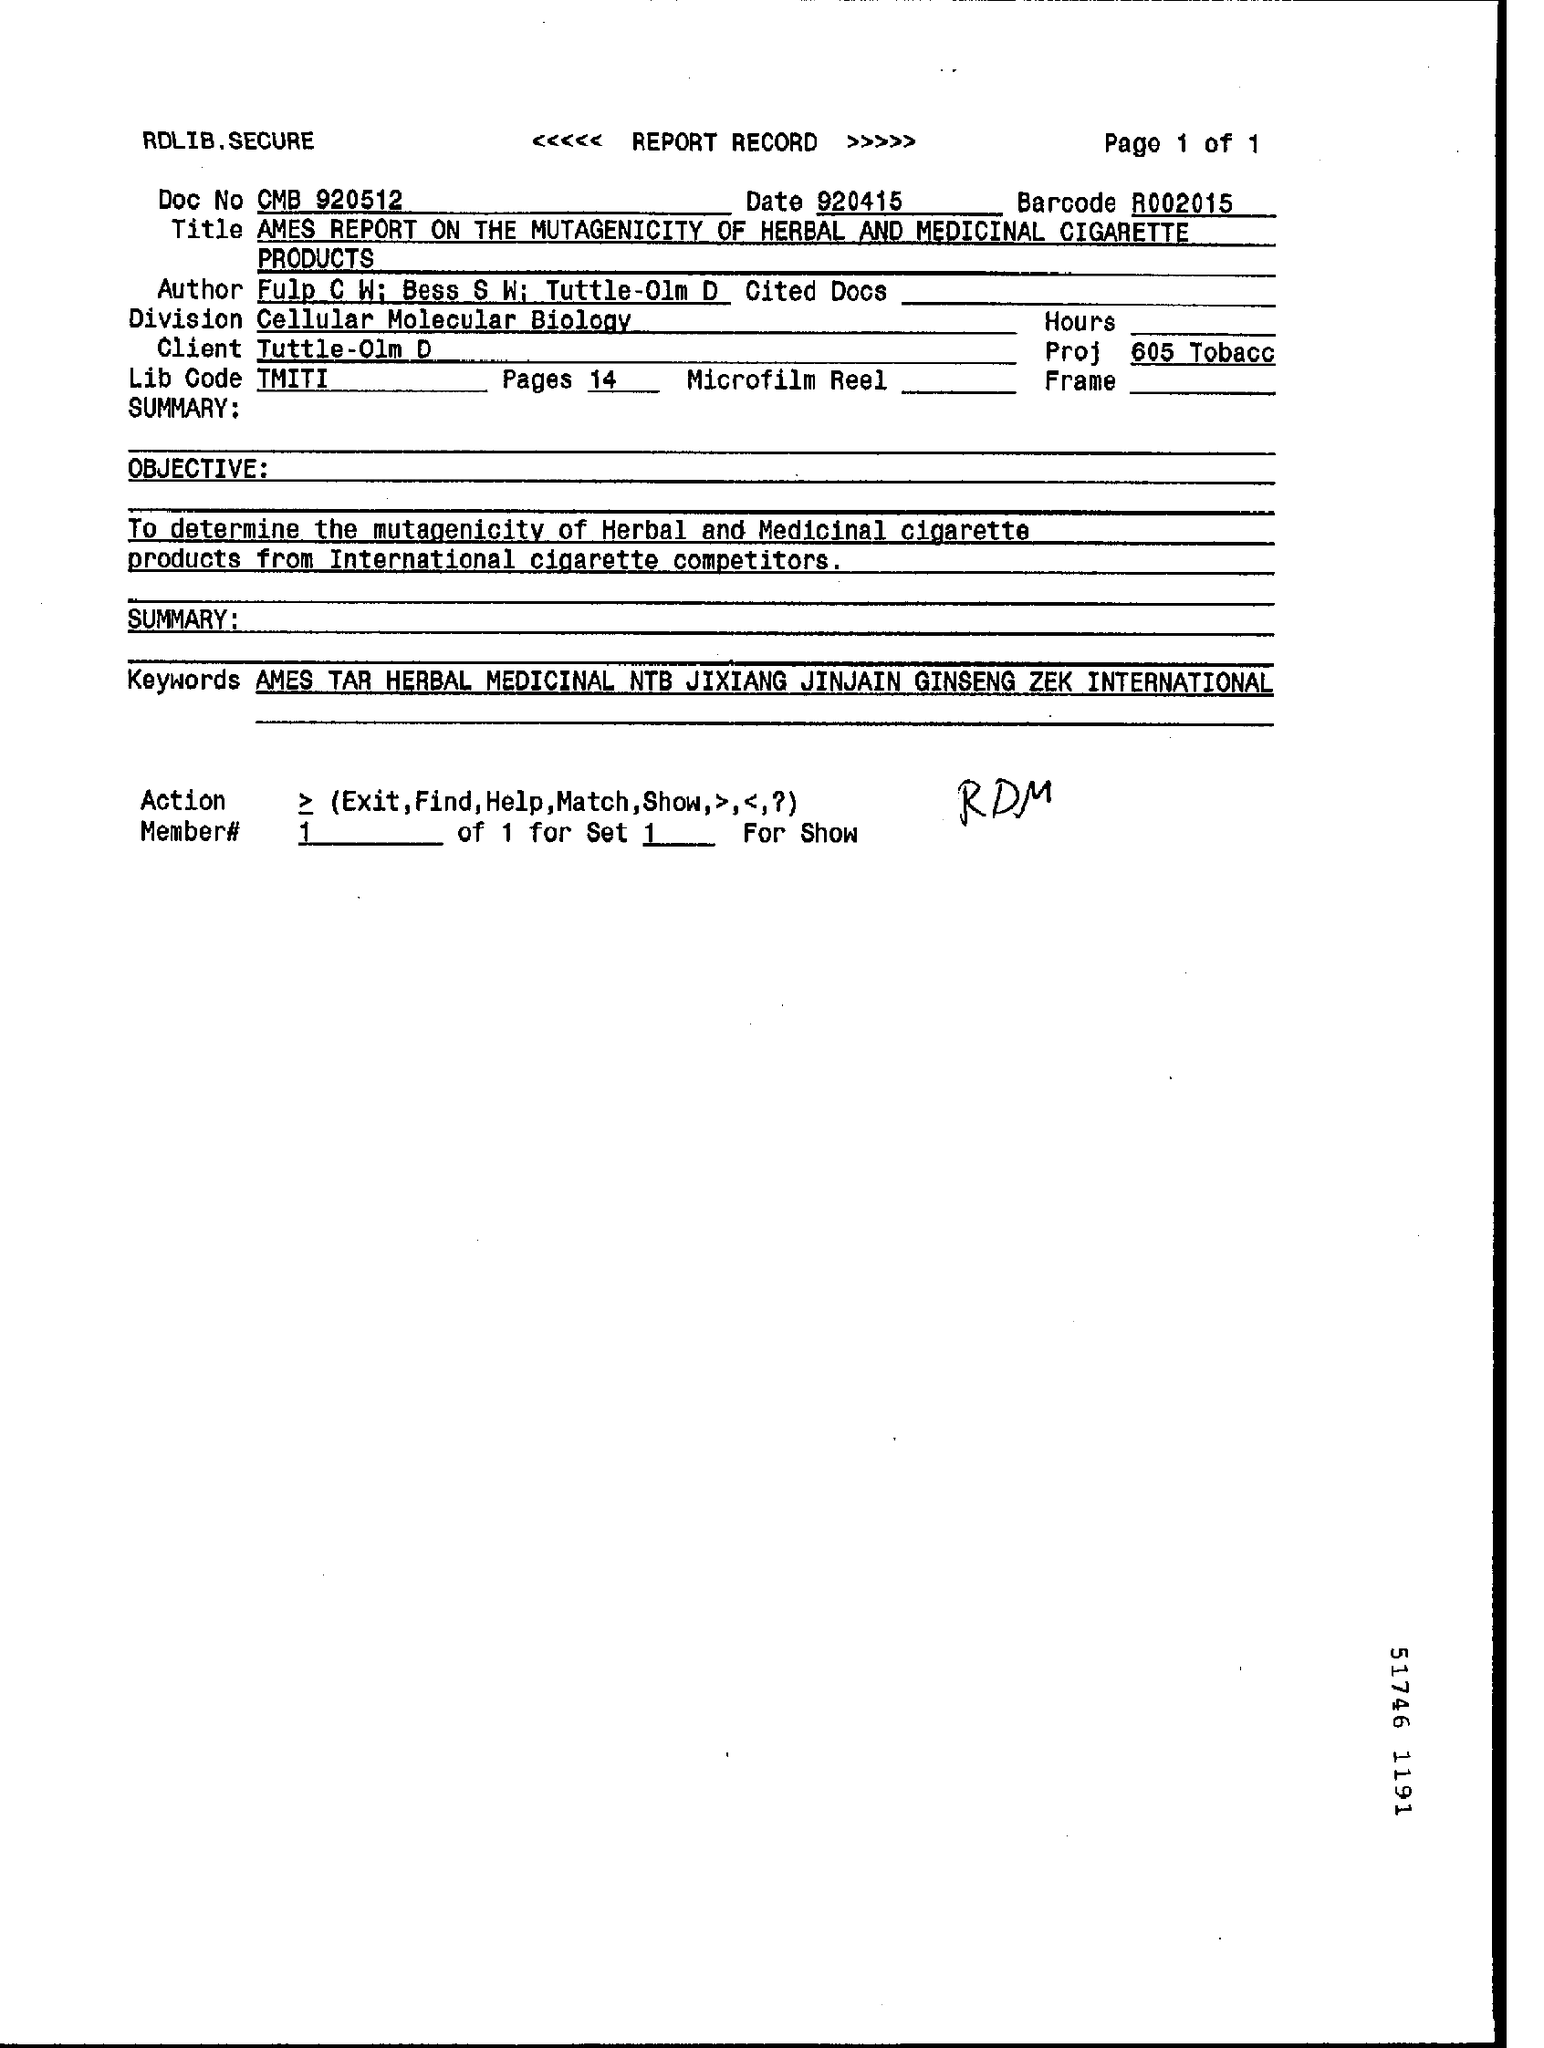How many pages are there in total?
Keep it short and to the point. 14. 